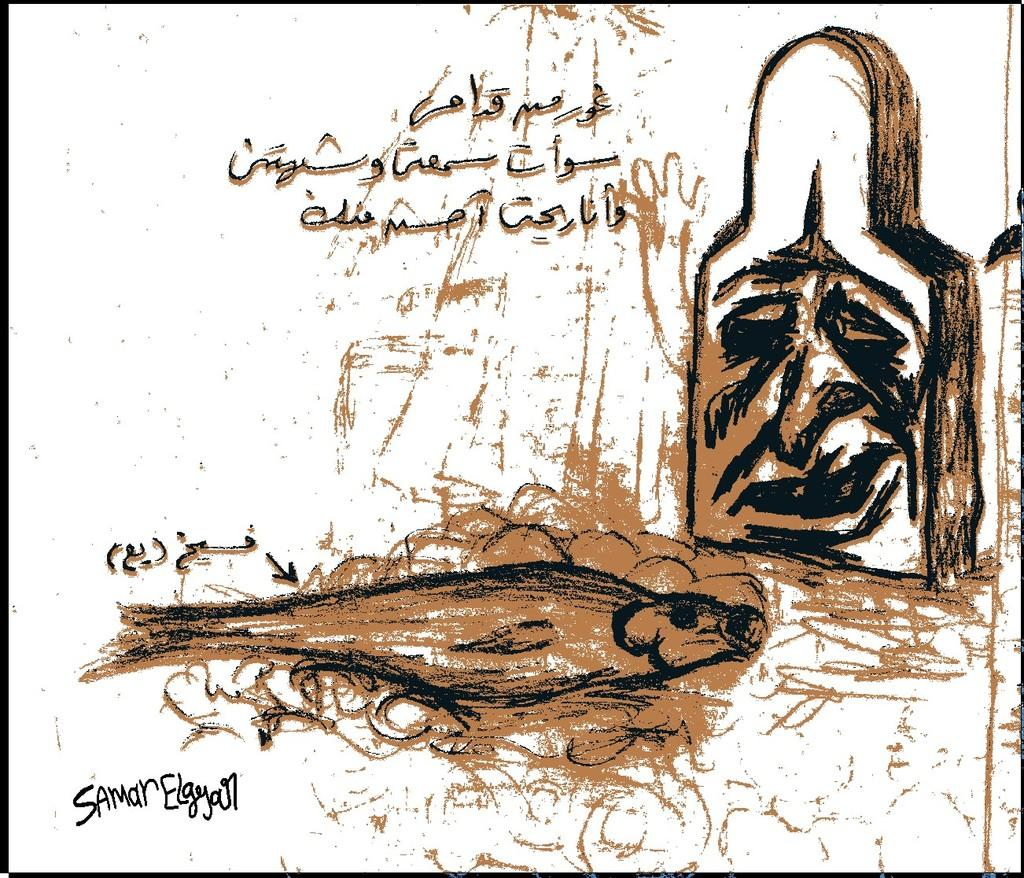What is the main subject of the picture? The main subject of the picture is an art piece. How is the art piece depicted in the image? The art piece resembles a gravestone on the right side. What can be seen at the top of the picture? There is text visible in the top of the picture. What color is the background of the image? The background of the image is white. How many oranges are placed in the basket in the middle of the image? There is no basket or oranges present in the image. 